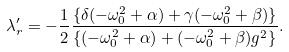Convert formula to latex. <formula><loc_0><loc_0><loc_500><loc_500>\lambda ^ { \prime } _ { r } = - \frac { 1 } { 2 } \frac { \{ \delta ( - \omega _ { 0 } ^ { 2 } + \alpha ) + \gamma ( - \omega _ { 0 } ^ { 2 } + \beta ) \} } { \{ ( - \omega _ { 0 } ^ { 2 } + \alpha ) + ( - \omega _ { 0 } ^ { 2 } + \beta ) g ^ { 2 } \} } .</formula> 